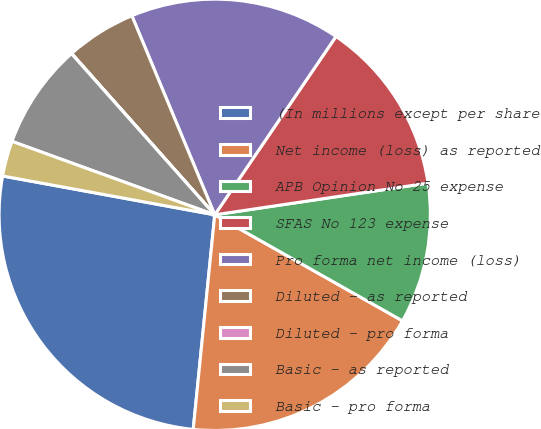<chart> <loc_0><loc_0><loc_500><loc_500><pie_chart><fcel>(In millions except per share<fcel>Net income (loss) as reported<fcel>APB Opinion No 25 expense<fcel>SFAS No 123 expense<fcel>Pro forma net income (loss)<fcel>Diluted - as reported<fcel>Diluted - pro forma<fcel>Basic - as reported<fcel>Basic - pro forma<nl><fcel>26.29%<fcel>18.41%<fcel>10.53%<fcel>13.15%<fcel>15.78%<fcel>5.27%<fcel>0.02%<fcel>7.9%<fcel>2.65%<nl></chart> 